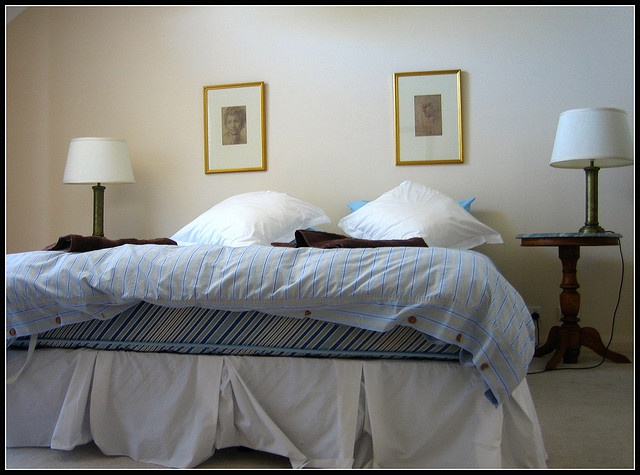Describe the objects in this image and their specific colors. I can see a bed in black, gray, darkgray, and lightgray tones in this image. 